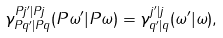<formula> <loc_0><loc_0><loc_500><loc_500>\gamma ^ { P j ^ { \prime } | P j } _ { P q ^ { \prime } | P q } ( P \omega ^ { \prime } | P \omega ) = \gamma ^ { j ^ { \prime } | j } _ { q ^ { \prime } | q } ( \omega ^ { \prime } | \omega ) ,</formula> 